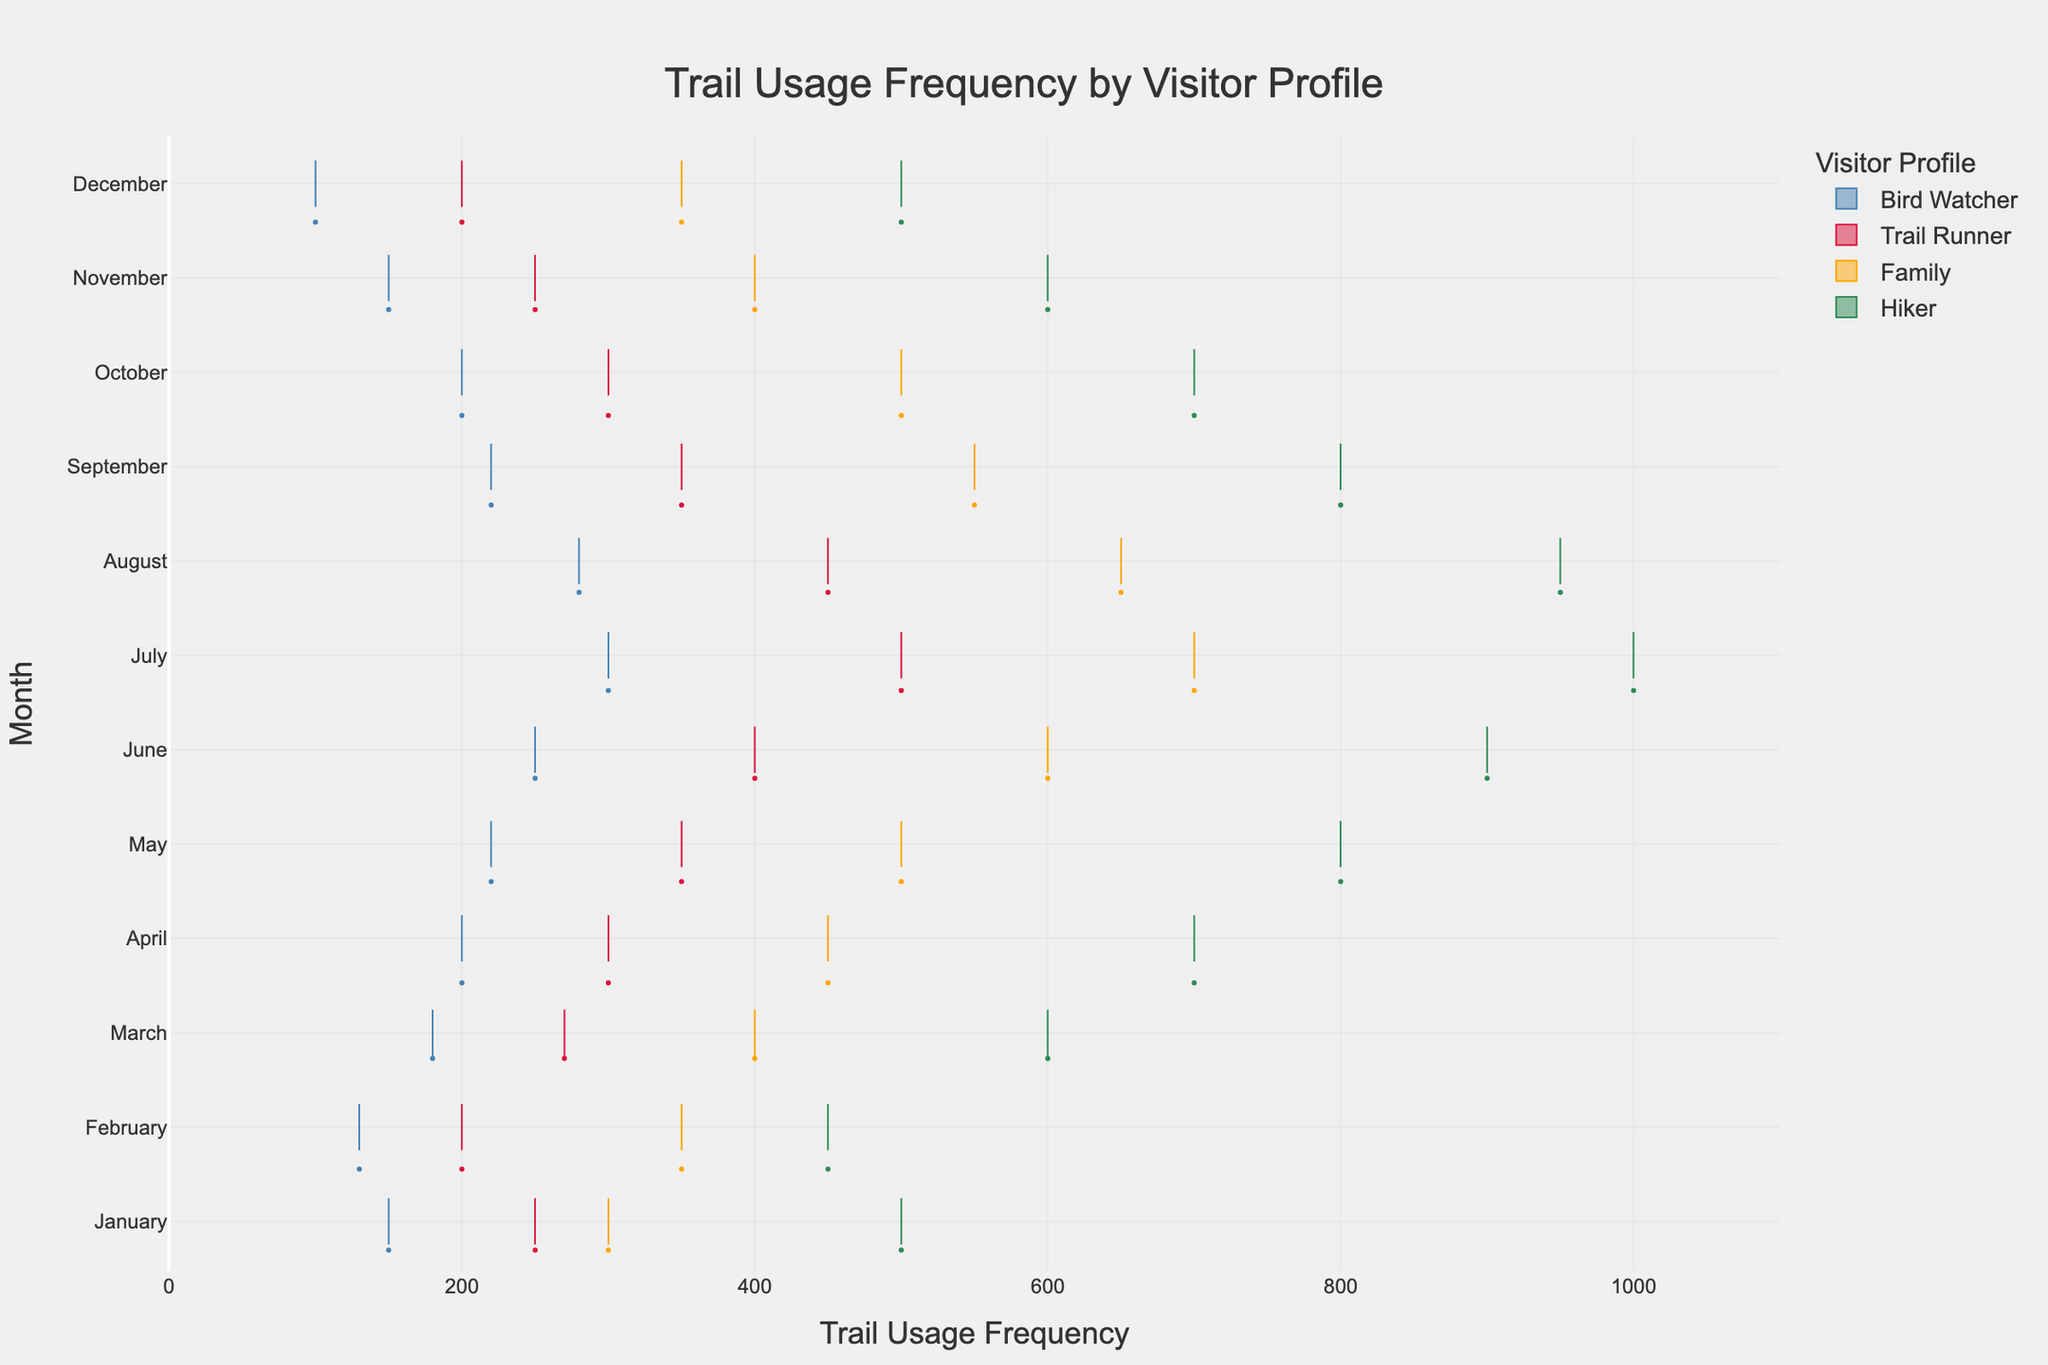what is the title of this figure? The title is typically located at the top of the figure and it identifies the main subject of the plot. By looking at the figure, you can see the large text at the top that indicates the title.
Answer: Trail Usage Frequency by Visitor Profile What is the color associated with the 'Hiker' visitor profile? The color associated with each visitor profile is distinctly represented in the legend on the right side of the figure. Find the 'Hiker' label and note its corresponding color.
Answer: Green Which month has the highest trail usage frequency for the 'Trail Runner' profile? To answer this, look at the position and spread of the 'Trail Runner' data points along the y-axis across all the months. Identify the month with the data points clustered towards the higher end of the x-axis.
Answer: July In which month does the 'Family' profile show the lowest trail usage frequency? Identify the range and quartile of the 'Family' profile for each month by looking at the box plot elements. The whiskers and boxes indicate the spread and the lowest outliers. Compare across months to find the one with the lowest lower whisker or box extremity.
Answer: February Compare the median trail usage frequency for 'Hiker' and 'Bird Watcher' profiles in May. Which one is higher? Locate the May data points for both 'Hiker' and 'Bird Watcher' profiles. Find the central line within the boxes (which represents the median). Compare these lines' positions along the x-axis to determine which is higher.
Answer: Hiker How many visitor profiles are represented in the plot? The legend on the right side of the figure lists all the visitor profiles included in the plot. Count the distinct labels to determine the number of profiles.
Answer: Four On average, which visitor profile uses the trail more in the summer months (June, July, and August)? Sum the trail usage frequencies for June, July, and August for each visitor profile. Determine the average by dividing by three. Compare the averages across profiles to find the highest one.
Answer: Hiker Which visitor profile has the widest range of trail usage distribution in October? Look at the box plots for October across all profiles. The range is indicated by the distance between the lowest whisker and the highest whisker (or outliers). Compare the lengths of these ranges to find the widest.
Answer: Family Is there a clear seasonal trend in trail usage for the 'Bird Watcher' profile? Examine the spread and position of the 'Bird Watcher' data points across all months. Look for consistent patterns indicating increases or decreases in frequency over time.
Answer: No Between January and December, does the 'Trail Runner' profile show an increasing or decreasing trend in trail usage frequency? Track the position of 'Trail Runner' boxplots for each month sequentially from January to December. Observe if the central points (medians) move higher or lower along the x-axis over time.
Answer: Decreasing 